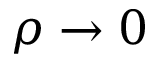Convert formula to latex. <formula><loc_0><loc_0><loc_500><loc_500>\rho \rightarrow 0</formula> 